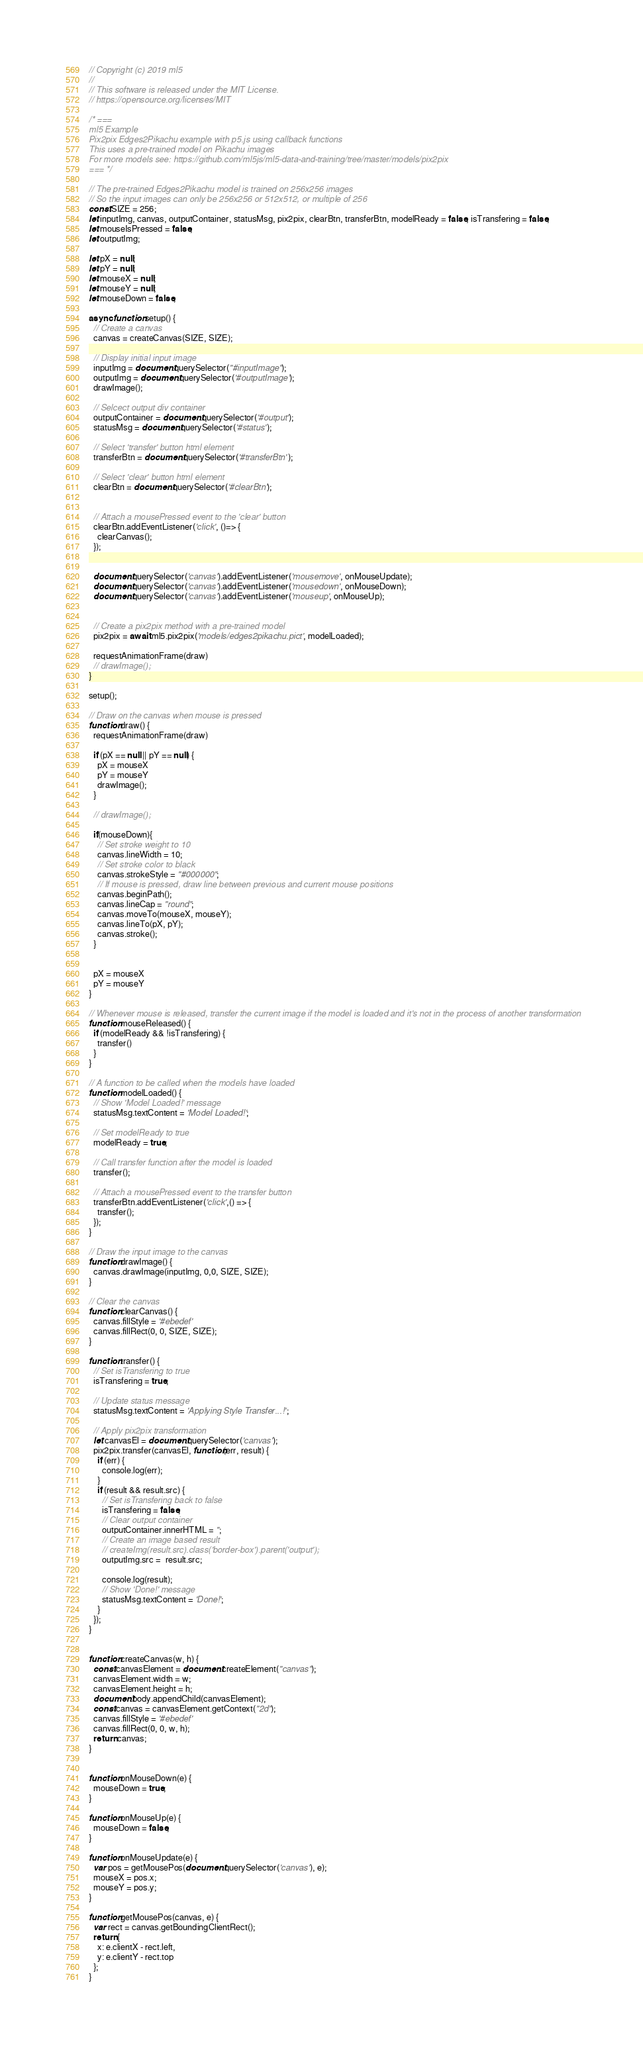Convert code to text. <code><loc_0><loc_0><loc_500><loc_500><_JavaScript_>// Copyright (c) 2019 ml5
//
// This software is released under the MIT License.
// https://opensource.org/licenses/MIT

/* ===
ml5 Example
Pix2pix Edges2Pikachu example with p5.js using callback functions
This uses a pre-trained model on Pikachu images
For more models see: https://github.com/ml5js/ml5-data-and-training/tree/master/models/pix2pix
=== */

// The pre-trained Edges2Pikachu model is trained on 256x256 images
// So the input images can only be 256x256 or 512x512, or multiple of 256
const SIZE = 256;
let inputImg, canvas, outputContainer, statusMsg, pix2pix, clearBtn, transferBtn, modelReady = false, isTransfering = false;
let mouseIsPressed = false;
let outputImg;

let pX = null;
let pY = null;
let mouseX = null;
let mouseY = null;
let mouseDown = false;

async function setup() {
  // Create a canvas
  canvas = createCanvas(SIZE, SIZE);

  // Display initial input image
  inputImg = document.querySelector("#inputImage");
  outputImg = document.querySelector('#outputImage');
  drawImage();

  // Selcect output div container
  outputContainer = document.querySelector('#output');
  statusMsg = document.querySelector('#status');

  // Select 'transfer' button html element
  transferBtn = document.querySelector('#transferBtn');

  // Select 'clear' button html element
  clearBtn = document.querySelector('#clearBtn');


  // Attach a mousePressed event to the 'clear' button
  clearBtn.addEventListener('click', ()=> {
    clearCanvas();
  });


  document.querySelector('canvas').addEventListener('mousemove', onMouseUpdate);
  document.querySelector('canvas').addEventListener('mousedown', onMouseDown);
  document.querySelector('canvas').addEventListener('mouseup', onMouseUp);


  // Create a pix2pix method with a pre-trained model
  pix2pix = await ml5.pix2pix('models/edges2pikachu.pict', modelLoaded);

  requestAnimationFrame(draw)
  // drawImage();
}

setup();

// Draw on the canvas when mouse is pressed
function draw() {
  requestAnimationFrame(draw)

  if (pX == null || pY == null) {
    pX = mouseX
    pY = mouseY
    drawImage();
  }  

  // drawImage();

  if(mouseDown){
    // Set stroke weight to 10
    canvas.lineWidth = 10;
    // Set stroke color to black
    canvas.strokeStyle = "#000000";
    // If mouse is pressed, draw line between previous and current mouse positions
    canvas.beginPath();
    canvas.lineCap = "round";
    canvas.moveTo(mouseX, mouseY);
    canvas.lineTo(pX, pY);
    canvas.stroke();
  }
  

  pX = mouseX
  pY = mouseY
}

// Whenever mouse is released, transfer the current image if the model is loaded and it's not in the process of another transformation
function mouseReleased() {
  if (modelReady && !isTransfering) {
    transfer()
  }
}

// A function to be called when the models have loaded
function modelLoaded() {
  // Show 'Model Loaded!' message
  statusMsg.textContent = 'Model Loaded!';

  // Set modelReady to true
  modelReady = true;

  // Call transfer function after the model is loaded
  transfer();

  // Attach a mousePressed event to the transfer button
  transferBtn.addEventListener('click',() => {
    transfer();
  });
}

// Draw the input image to the canvas
function drawImage() {
  canvas.drawImage(inputImg, 0,0, SIZE, SIZE);
}

// Clear the canvas
function clearCanvas() {
  canvas.fillStyle = '#ebedef'
  canvas.fillRect(0, 0, SIZE, SIZE);
}

function transfer() {
  // Set isTransfering to true
  isTransfering = true;

  // Update status message
  statusMsg.textContent = 'Applying Style Transfer...!';

  // Apply pix2pix transformation
  let canvasEl = document.querySelector('canvas');
  pix2pix.transfer(canvasEl, function(err, result) {
    if (err) {
      console.log(err);
    }
    if (result && result.src) {
      // Set isTransfering back to false
      isTransfering = false;
      // Clear output container
      outputContainer.innerHTML = '';
      // Create an image based result
      // createImg(result.src).class('border-box').parent('output');
      outputImg.src =  result.src;

      console.log(result);
      // Show 'Done!' message
      statusMsg.textContent = 'Done!';
    }
  });
}


function createCanvas(w, h) {
  const canvasElement = document.createElement("canvas");
  canvasElement.width = w;
  canvasElement.height = h;
  document.body.appendChild(canvasElement);
  const canvas = canvasElement.getContext("2d");
  canvas.fillStyle = '#ebedef'
  canvas.fillRect(0, 0, w, h);
  return canvas;
}


function onMouseDown(e) {
  mouseDown = true;
}

function onMouseUp(e) {
  mouseDown = false;
}

function onMouseUpdate(e) {
  var pos = getMousePos(document.querySelector('canvas'), e);
  mouseX = pos.x;
  mouseY = pos.y;
}

function getMousePos(canvas, e) {
  var rect = canvas.getBoundingClientRect();
  return {
    x: e.clientX - rect.left,
    y: e.clientY - rect.top
  };
}</code> 